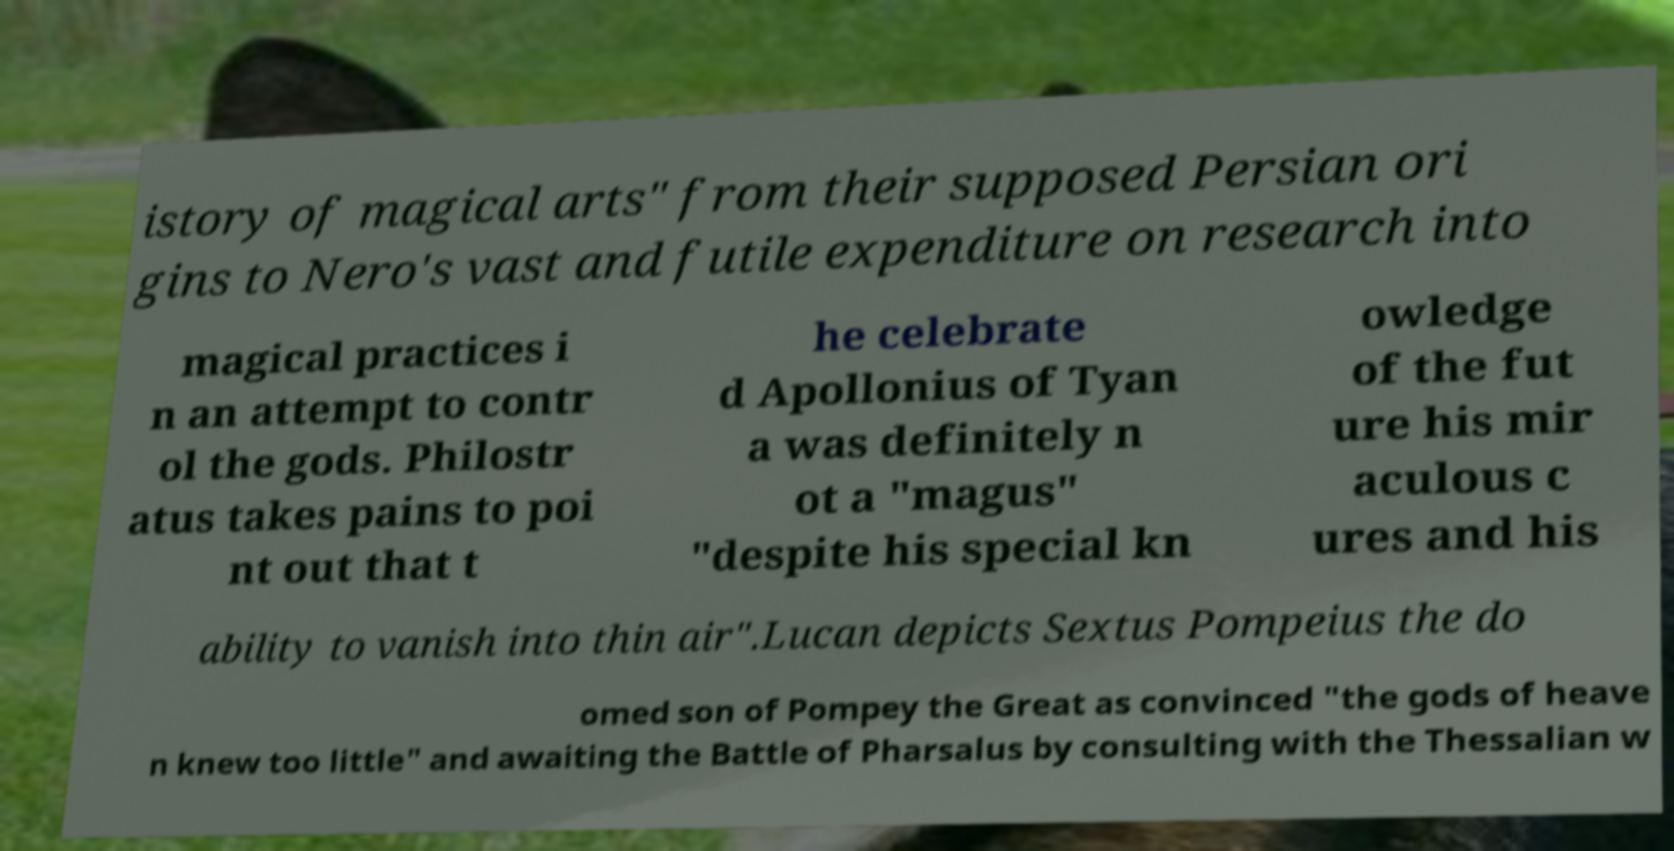Please read and relay the text visible in this image. What does it say? istory of magical arts" from their supposed Persian ori gins to Nero's vast and futile expenditure on research into magical practices i n an attempt to contr ol the gods. Philostr atus takes pains to poi nt out that t he celebrate d Apollonius of Tyan a was definitely n ot a "magus" "despite his special kn owledge of the fut ure his mir aculous c ures and his ability to vanish into thin air".Lucan depicts Sextus Pompeius the do omed son of Pompey the Great as convinced "the gods of heave n knew too little" and awaiting the Battle of Pharsalus by consulting with the Thessalian w 